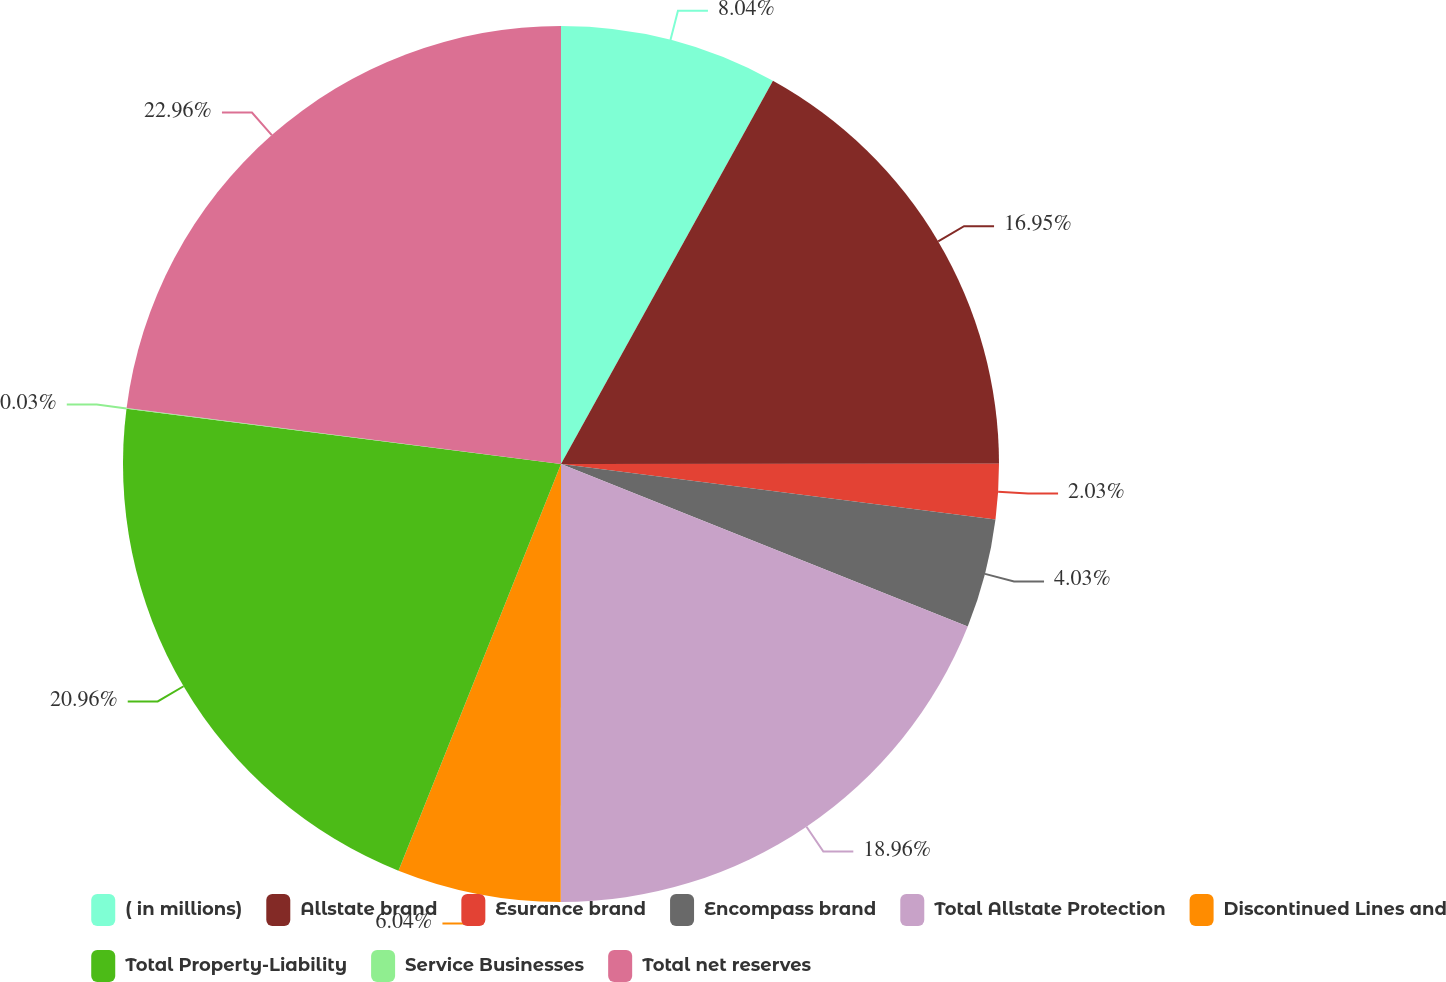Convert chart to OTSL. <chart><loc_0><loc_0><loc_500><loc_500><pie_chart><fcel>( in millions)<fcel>Allstate brand<fcel>Esurance brand<fcel>Encompass brand<fcel>Total Allstate Protection<fcel>Discontinued Lines and<fcel>Total Property-Liability<fcel>Service Businesses<fcel>Total net reserves<nl><fcel>8.04%<fcel>16.95%<fcel>2.03%<fcel>4.03%<fcel>18.96%<fcel>6.04%<fcel>20.96%<fcel>0.03%<fcel>22.96%<nl></chart> 